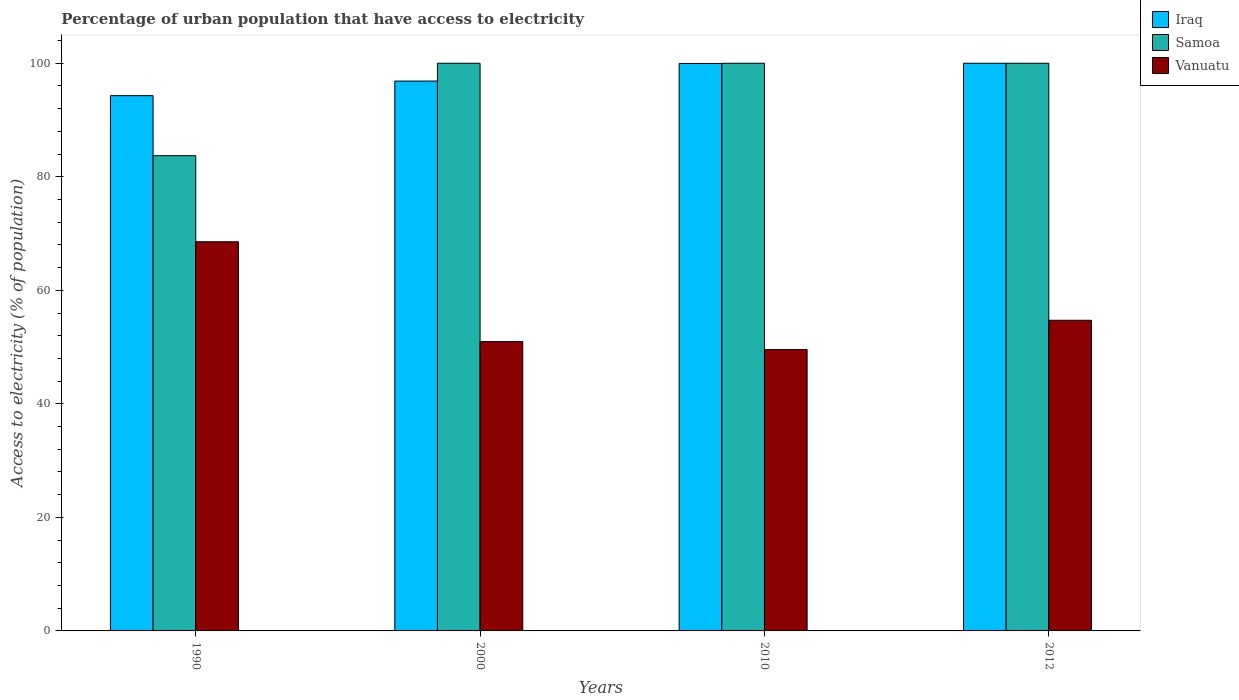How many groups of bars are there?
Provide a succinct answer. 4. Are the number of bars on each tick of the X-axis equal?
Give a very brief answer. Yes. How many bars are there on the 4th tick from the right?
Your response must be concise. 3. What is the label of the 1st group of bars from the left?
Provide a short and direct response. 1990. What is the percentage of urban population that have access to electricity in Samoa in 1990?
Provide a short and direct response. 83.72. Across all years, what is the minimum percentage of urban population that have access to electricity in Iraq?
Your answer should be very brief. 94.29. In which year was the percentage of urban population that have access to electricity in Iraq minimum?
Provide a succinct answer. 1990. What is the total percentage of urban population that have access to electricity in Samoa in the graph?
Provide a succinct answer. 383.72. What is the difference between the percentage of urban population that have access to electricity in Iraq in 1990 and that in 2010?
Your answer should be very brief. -5.67. What is the difference between the percentage of urban population that have access to electricity in Vanuatu in 2000 and the percentage of urban population that have access to electricity in Iraq in 2010?
Give a very brief answer. -48.99. What is the average percentage of urban population that have access to electricity in Iraq per year?
Provide a short and direct response. 97.78. In the year 2000, what is the difference between the percentage of urban population that have access to electricity in Vanuatu and percentage of urban population that have access to electricity in Iraq?
Give a very brief answer. -45.89. In how many years, is the percentage of urban population that have access to electricity in Vanuatu greater than 32 %?
Your response must be concise. 4. What is the ratio of the percentage of urban population that have access to electricity in Samoa in 1990 to that in 2010?
Your answer should be very brief. 0.84. Is the percentage of urban population that have access to electricity in Vanuatu in 1990 less than that in 2012?
Make the answer very short. No. Is the difference between the percentage of urban population that have access to electricity in Vanuatu in 2010 and 2012 greater than the difference between the percentage of urban population that have access to electricity in Iraq in 2010 and 2012?
Your answer should be very brief. No. What is the difference between the highest and the lowest percentage of urban population that have access to electricity in Samoa?
Provide a succinct answer. 16.28. In how many years, is the percentage of urban population that have access to electricity in Samoa greater than the average percentage of urban population that have access to electricity in Samoa taken over all years?
Your response must be concise. 3. Is the sum of the percentage of urban population that have access to electricity in Iraq in 2000 and 2010 greater than the maximum percentage of urban population that have access to electricity in Vanuatu across all years?
Provide a short and direct response. Yes. What does the 2nd bar from the left in 2000 represents?
Provide a succinct answer. Samoa. What does the 3rd bar from the right in 2000 represents?
Your response must be concise. Iraq. How many bars are there?
Your answer should be very brief. 12. Are all the bars in the graph horizontal?
Provide a succinct answer. No. What is the difference between two consecutive major ticks on the Y-axis?
Your answer should be compact. 20. Where does the legend appear in the graph?
Your response must be concise. Top right. How many legend labels are there?
Offer a terse response. 3. How are the legend labels stacked?
Offer a terse response. Vertical. What is the title of the graph?
Provide a short and direct response. Percentage of urban population that have access to electricity. What is the label or title of the Y-axis?
Ensure brevity in your answer.  Access to electricity (% of population). What is the Access to electricity (% of population) of Iraq in 1990?
Provide a succinct answer. 94.29. What is the Access to electricity (% of population) of Samoa in 1990?
Your answer should be very brief. 83.72. What is the Access to electricity (% of population) of Vanuatu in 1990?
Provide a short and direct response. 68.56. What is the Access to electricity (% of population) of Iraq in 2000?
Your response must be concise. 96.86. What is the Access to electricity (% of population) in Vanuatu in 2000?
Your response must be concise. 50.97. What is the Access to electricity (% of population) of Iraq in 2010?
Make the answer very short. 99.96. What is the Access to electricity (% of population) of Samoa in 2010?
Ensure brevity in your answer.  100. What is the Access to electricity (% of population) in Vanuatu in 2010?
Your response must be concise. 49.57. What is the Access to electricity (% of population) in Vanuatu in 2012?
Offer a very short reply. 54.72. Across all years, what is the maximum Access to electricity (% of population) of Iraq?
Your answer should be compact. 100. Across all years, what is the maximum Access to electricity (% of population) of Vanuatu?
Give a very brief answer. 68.56. Across all years, what is the minimum Access to electricity (% of population) of Iraq?
Your response must be concise. 94.29. Across all years, what is the minimum Access to electricity (% of population) of Samoa?
Your answer should be compact. 83.72. Across all years, what is the minimum Access to electricity (% of population) of Vanuatu?
Offer a very short reply. 49.57. What is the total Access to electricity (% of population) of Iraq in the graph?
Provide a succinct answer. 391.12. What is the total Access to electricity (% of population) in Samoa in the graph?
Offer a terse response. 383.72. What is the total Access to electricity (% of population) in Vanuatu in the graph?
Make the answer very short. 223.82. What is the difference between the Access to electricity (% of population) in Iraq in 1990 and that in 2000?
Keep it short and to the point. -2.57. What is the difference between the Access to electricity (% of population) in Samoa in 1990 and that in 2000?
Your answer should be very brief. -16.28. What is the difference between the Access to electricity (% of population) in Vanuatu in 1990 and that in 2000?
Offer a terse response. 17.58. What is the difference between the Access to electricity (% of population) of Iraq in 1990 and that in 2010?
Your answer should be compact. -5.67. What is the difference between the Access to electricity (% of population) in Samoa in 1990 and that in 2010?
Your answer should be very brief. -16.28. What is the difference between the Access to electricity (% of population) of Vanuatu in 1990 and that in 2010?
Give a very brief answer. 18.99. What is the difference between the Access to electricity (% of population) of Iraq in 1990 and that in 2012?
Make the answer very short. -5.71. What is the difference between the Access to electricity (% of population) in Samoa in 1990 and that in 2012?
Provide a succinct answer. -16.28. What is the difference between the Access to electricity (% of population) of Vanuatu in 1990 and that in 2012?
Your answer should be very brief. 13.83. What is the difference between the Access to electricity (% of population) in Iraq in 2000 and that in 2010?
Your answer should be compact. -3.1. What is the difference between the Access to electricity (% of population) in Samoa in 2000 and that in 2010?
Make the answer very short. 0. What is the difference between the Access to electricity (% of population) in Vanuatu in 2000 and that in 2010?
Your answer should be compact. 1.41. What is the difference between the Access to electricity (% of population) of Iraq in 2000 and that in 2012?
Give a very brief answer. -3.14. What is the difference between the Access to electricity (% of population) of Vanuatu in 2000 and that in 2012?
Offer a very short reply. -3.75. What is the difference between the Access to electricity (% of population) in Iraq in 2010 and that in 2012?
Provide a short and direct response. -0.04. What is the difference between the Access to electricity (% of population) of Samoa in 2010 and that in 2012?
Your response must be concise. 0. What is the difference between the Access to electricity (% of population) of Vanuatu in 2010 and that in 2012?
Your response must be concise. -5.16. What is the difference between the Access to electricity (% of population) of Iraq in 1990 and the Access to electricity (% of population) of Samoa in 2000?
Your answer should be very brief. -5.71. What is the difference between the Access to electricity (% of population) of Iraq in 1990 and the Access to electricity (% of population) of Vanuatu in 2000?
Provide a short and direct response. 43.32. What is the difference between the Access to electricity (% of population) in Samoa in 1990 and the Access to electricity (% of population) in Vanuatu in 2000?
Your response must be concise. 32.74. What is the difference between the Access to electricity (% of population) in Iraq in 1990 and the Access to electricity (% of population) in Samoa in 2010?
Provide a succinct answer. -5.71. What is the difference between the Access to electricity (% of population) of Iraq in 1990 and the Access to electricity (% of population) of Vanuatu in 2010?
Your answer should be compact. 44.72. What is the difference between the Access to electricity (% of population) of Samoa in 1990 and the Access to electricity (% of population) of Vanuatu in 2010?
Ensure brevity in your answer.  34.15. What is the difference between the Access to electricity (% of population) in Iraq in 1990 and the Access to electricity (% of population) in Samoa in 2012?
Offer a very short reply. -5.71. What is the difference between the Access to electricity (% of population) of Iraq in 1990 and the Access to electricity (% of population) of Vanuatu in 2012?
Give a very brief answer. 39.57. What is the difference between the Access to electricity (% of population) of Samoa in 1990 and the Access to electricity (% of population) of Vanuatu in 2012?
Offer a very short reply. 28.99. What is the difference between the Access to electricity (% of population) in Iraq in 2000 and the Access to electricity (% of population) in Samoa in 2010?
Give a very brief answer. -3.14. What is the difference between the Access to electricity (% of population) in Iraq in 2000 and the Access to electricity (% of population) in Vanuatu in 2010?
Your response must be concise. 47.29. What is the difference between the Access to electricity (% of population) in Samoa in 2000 and the Access to electricity (% of population) in Vanuatu in 2010?
Make the answer very short. 50.43. What is the difference between the Access to electricity (% of population) of Iraq in 2000 and the Access to electricity (% of population) of Samoa in 2012?
Offer a terse response. -3.14. What is the difference between the Access to electricity (% of population) of Iraq in 2000 and the Access to electricity (% of population) of Vanuatu in 2012?
Your answer should be compact. 42.14. What is the difference between the Access to electricity (% of population) in Samoa in 2000 and the Access to electricity (% of population) in Vanuatu in 2012?
Give a very brief answer. 45.27. What is the difference between the Access to electricity (% of population) in Iraq in 2010 and the Access to electricity (% of population) in Samoa in 2012?
Offer a terse response. -0.04. What is the difference between the Access to electricity (% of population) in Iraq in 2010 and the Access to electricity (% of population) in Vanuatu in 2012?
Give a very brief answer. 45.24. What is the difference between the Access to electricity (% of population) of Samoa in 2010 and the Access to electricity (% of population) of Vanuatu in 2012?
Your answer should be compact. 45.27. What is the average Access to electricity (% of population) of Iraq per year?
Ensure brevity in your answer.  97.78. What is the average Access to electricity (% of population) of Samoa per year?
Offer a very short reply. 95.93. What is the average Access to electricity (% of population) of Vanuatu per year?
Your answer should be compact. 55.96. In the year 1990, what is the difference between the Access to electricity (% of population) of Iraq and Access to electricity (% of population) of Samoa?
Your response must be concise. 10.57. In the year 1990, what is the difference between the Access to electricity (% of population) of Iraq and Access to electricity (% of population) of Vanuatu?
Provide a succinct answer. 25.74. In the year 1990, what is the difference between the Access to electricity (% of population) of Samoa and Access to electricity (% of population) of Vanuatu?
Provide a short and direct response. 15.16. In the year 2000, what is the difference between the Access to electricity (% of population) of Iraq and Access to electricity (% of population) of Samoa?
Your answer should be compact. -3.14. In the year 2000, what is the difference between the Access to electricity (% of population) of Iraq and Access to electricity (% of population) of Vanuatu?
Ensure brevity in your answer.  45.89. In the year 2000, what is the difference between the Access to electricity (% of population) in Samoa and Access to electricity (% of population) in Vanuatu?
Offer a very short reply. 49.03. In the year 2010, what is the difference between the Access to electricity (% of population) in Iraq and Access to electricity (% of population) in Samoa?
Make the answer very short. -0.04. In the year 2010, what is the difference between the Access to electricity (% of population) in Iraq and Access to electricity (% of population) in Vanuatu?
Ensure brevity in your answer.  50.39. In the year 2010, what is the difference between the Access to electricity (% of population) in Samoa and Access to electricity (% of population) in Vanuatu?
Make the answer very short. 50.43. In the year 2012, what is the difference between the Access to electricity (% of population) in Iraq and Access to electricity (% of population) in Vanuatu?
Your response must be concise. 45.27. In the year 2012, what is the difference between the Access to electricity (% of population) in Samoa and Access to electricity (% of population) in Vanuatu?
Give a very brief answer. 45.27. What is the ratio of the Access to electricity (% of population) of Iraq in 1990 to that in 2000?
Your response must be concise. 0.97. What is the ratio of the Access to electricity (% of population) in Samoa in 1990 to that in 2000?
Your answer should be very brief. 0.84. What is the ratio of the Access to electricity (% of population) of Vanuatu in 1990 to that in 2000?
Make the answer very short. 1.34. What is the ratio of the Access to electricity (% of population) in Iraq in 1990 to that in 2010?
Offer a terse response. 0.94. What is the ratio of the Access to electricity (% of population) in Samoa in 1990 to that in 2010?
Provide a short and direct response. 0.84. What is the ratio of the Access to electricity (% of population) in Vanuatu in 1990 to that in 2010?
Provide a short and direct response. 1.38. What is the ratio of the Access to electricity (% of population) of Iraq in 1990 to that in 2012?
Your answer should be compact. 0.94. What is the ratio of the Access to electricity (% of population) of Samoa in 1990 to that in 2012?
Make the answer very short. 0.84. What is the ratio of the Access to electricity (% of population) in Vanuatu in 1990 to that in 2012?
Provide a short and direct response. 1.25. What is the ratio of the Access to electricity (% of population) in Vanuatu in 2000 to that in 2010?
Your answer should be compact. 1.03. What is the ratio of the Access to electricity (% of population) in Iraq in 2000 to that in 2012?
Make the answer very short. 0.97. What is the ratio of the Access to electricity (% of population) in Samoa in 2000 to that in 2012?
Provide a short and direct response. 1. What is the ratio of the Access to electricity (% of population) in Vanuatu in 2000 to that in 2012?
Give a very brief answer. 0.93. What is the ratio of the Access to electricity (% of population) of Iraq in 2010 to that in 2012?
Your answer should be compact. 1. What is the ratio of the Access to electricity (% of population) of Vanuatu in 2010 to that in 2012?
Make the answer very short. 0.91. What is the difference between the highest and the second highest Access to electricity (% of population) of Iraq?
Your answer should be very brief. 0.04. What is the difference between the highest and the second highest Access to electricity (% of population) in Vanuatu?
Make the answer very short. 13.83. What is the difference between the highest and the lowest Access to electricity (% of population) of Iraq?
Offer a terse response. 5.71. What is the difference between the highest and the lowest Access to electricity (% of population) of Samoa?
Provide a short and direct response. 16.28. What is the difference between the highest and the lowest Access to electricity (% of population) of Vanuatu?
Your answer should be very brief. 18.99. 